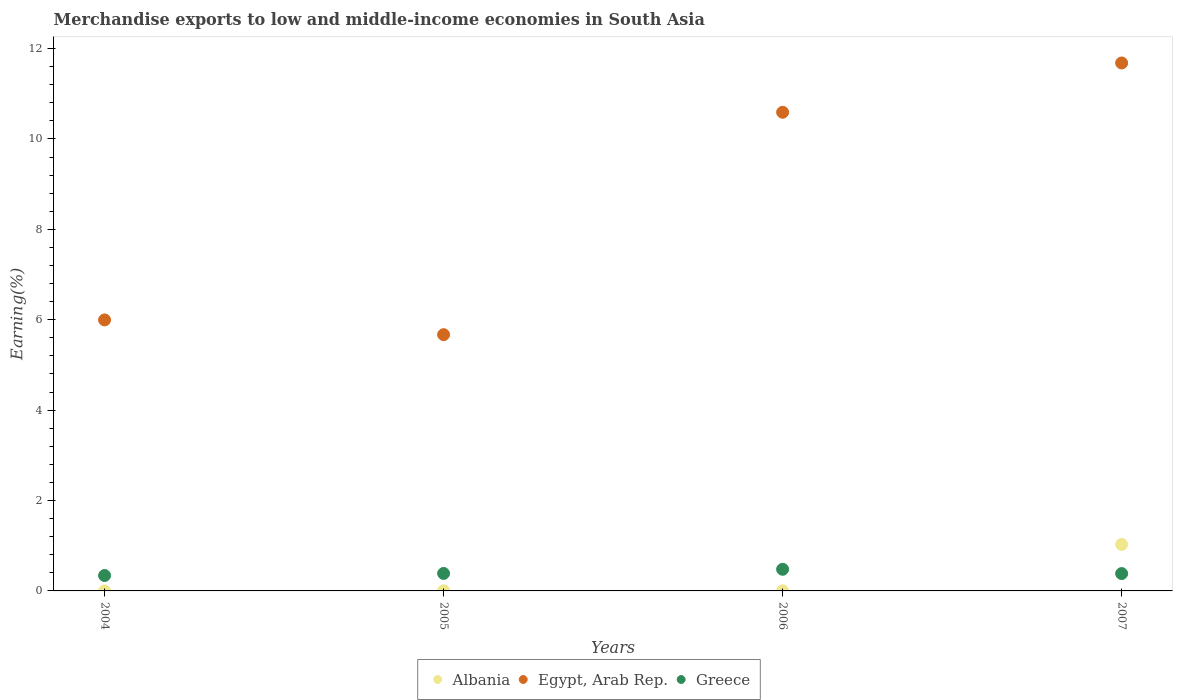Is the number of dotlines equal to the number of legend labels?
Offer a terse response. Yes. What is the percentage of amount earned from merchandise exports in Greece in 2005?
Your answer should be compact. 0.39. Across all years, what is the maximum percentage of amount earned from merchandise exports in Egypt, Arab Rep.?
Your answer should be compact. 11.68. Across all years, what is the minimum percentage of amount earned from merchandise exports in Greece?
Your response must be concise. 0.34. In which year was the percentage of amount earned from merchandise exports in Egypt, Arab Rep. minimum?
Your response must be concise. 2005. What is the total percentage of amount earned from merchandise exports in Egypt, Arab Rep. in the graph?
Provide a short and direct response. 33.94. What is the difference between the percentage of amount earned from merchandise exports in Greece in 2004 and that in 2007?
Offer a very short reply. -0.04. What is the difference between the percentage of amount earned from merchandise exports in Egypt, Arab Rep. in 2006 and the percentage of amount earned from merchandise exports in Greece in 2007?
Provide a succinct answer. 10.21. What is the average percentage of amount earned from merchandise exports in Albania per year?
Provide a succinct answer. 0.26. In the year 2007, what is the difference between the percentage of amount earned from merchandise exports in Greece and percentage of amount earned from merchandise exports in Egypt, Arab Rep.?
Offer a very short reply. -11.3. In how many years, is the percentage of amount earned from merchandise exports in Albania greater than 3.2 %?
Give a very brief answer. 0. What is the ratio of the percentage of amount earned from merchandise exports in Greece in 2006 to that in 2007?
Your response must be concise. 1.25. What is the difference between the highest and the second highest percentage of amount earned from merchandise exports in Greece?
Provide a short and direct response. 0.09. What is the difference between the highest and the lowest percentage of amount earned from merchandise exports in Albania?
Your answer should be compact. 1.03. Is the sum of the percentage of amount earned from merchandise exports in Albania in 2004 and 2006 greater than the maximum percentage of amount earned from merchandise exports in Egypt, Arab Rep. across all years?
Provide a succinct answer. No. Does the percentage of amount earned from merchandise exports in Greece monotonically increase over the years?
Ensure brevity in your answer.  No. Is the percentage of amount earned from merchandise exports in Greece strictly greater than the percentage of amount earned from merchandise exports in Albania over the years?
Keep it short and to the point. No. How many years are there in the graph?
Provide a short and direct response. 4. What is the difference between two consecutive major ticks on the Y-axis?
Provide a succinct answer. 2. Are the values on the major ticks of Y-axis written in scientific E-notation?
Give a very brief answer. No. Does the graph contain any zero values?
Your response must be concise. No. Does the graph contain grids?
Your answer should be very brief. No. How many legend labels are there?
Provide a succinct answer. 3. What is the title of the graph?
Offer a very short reply. Merchandise exports to low and middle-income economies in South Asia. What is the label or title of the X-axis?
Your answer should be compact. Years. What is the label or title of the Y-axis?
Keep it short and to the point. Earning(%). What is the Earning(%) in Albania in 2004?
Provide a succinct answer. 0. What is the Earning(%) in Egypt, Arab Rep. in 2004?
Give a very brief answer. 6. What is the Earning(%) of Greece in 2004?
Your answer should be very brief. 0.34. What is the Earning(%) in Albania in 2005?
Offer a terse response. 0. What is the Earning(%) of Egypt, Arab Rep. in 2005?
Your response must be concise. 5.67. What is the Earning(%) of Greece in 2005?
Make the answer very short. 0.39. What is the Earning(%) in Albania in 2006?
Keep it short and to the point. 0. What is the Earning(%) of Egypt, Arab Rep. in 2006?
Ensure brevity in your answer.  10.59. What is the Earning(%) of Greece in 2006?
Provide a succinct answer. 0.48. What is the Earning(%) of Albania in 2007?
Ensure brevity in your answer.  1.03. What is the Earning(%) of Egypt, Arab Rep. in 2007?
Offer a terse response. 11.68. What is the Earning(%) of Greece in 2007?
Ensure brevity in your answer.  0.38. Across all years, what is the maximum Earning(%) in Albania?
Offer a very short reply. 1.03. Across all years, what is the maximum Earning(%) of Egypt, Arab Rep.?
Offer a very short reply. 11.68. Across all years, what is the maximum Earning(%) of Greece?
Provide a succinct answer. 0.48. Across all years, what is the minimum Earning(%) of Albania?
Your answer should be compact. 0. Across all years, what is the minimum Earning(%) of Egypt, Arab Rep.?
Your answer should be compact. 5.67. Across all years, what is the minimum Earning(%) of Greece?
Offer a terse response. 0.34. What is the total Earning(%) in Albania in the graph?
Your answer should be very brief. 1.03. What is the total Earning(%) in Egypt, Arab Rep. in the graph?
Give a very brief answer. 33.94. What is the total Earning(%) in Greece in the graph?
Your response must be concise. 1.59. What is the difference between the Earning(%) of Albania in 2004 and that in 2005?
Make the answer very short. -0. What is the difference between the Earning(%) in Egypt, Arab Rep. in 2004 and that in 2005?
Provide a succinct answer. 0.33. What is the difference between the Earning(%) of Greece in 2004 and that in 2005?
Offer a very short reply. -0.05. What is the difference between the Earning(%) of Albania in 2004 and that in 2006?
Your answer should be compact. -0. What is the difference between the Earning(%) in Egypt, Arab Rep. in 2004 and that in 2006?
Ensure brevity in your answer.  -4.59. What is the difference between the Earning(%) in Greece in 2004 and that in 2006?
Your response must be concise. -0.14. What is the difference between the Earning(%) in Albania in 2004 and that in 2007?
Your answer should be compact. -1.03. What is the difference between the Earning(%) in Egypt, Arab Rep. in 2004 and that in 2007?
Keep it short and to the point. -5.69. What is the difference between the Earning(%) in Greece in 2004 and that in 2007?
Keep it short and to the point. -0.04. What is the difference between the Earning(%) of Albania in 2005 and that in 2006?
Offer a very short reply. 0. What is the difference between the Earning(%) of Egypt, Arab Rep. in 2005 and that in 2006?
Offer a very short reply. -4.92. What is the difference between the Earning(%) in Greece in 2005 and that in 2006?
Offer a terse response. -0.09. What is the difference between the Earning(%) in Albania in 2005 and that in 2007?
Offer a terse response. -1.03. What is the difference between the Earning(%) of Egypt, Arab Rep. in 2005 and that in 2007?
Keep it short and to the point. -6.01. What is the difference between the Earning(%) in Greece in 2005 and that in 2007?
Give a very brief answer. 0. What is the difference between the Earning(%) of Albania in 2006 and that in 2007?
Offer a very short reply. -1.03. What is the difference between the Earning(%) in Egypt, Arab Rep. in 2006 and that in 2007?
Provide a short and direct response. -1.09. What is the difference between the Earning(%) in Greece in 2006 and that in 2007?
Your answer should be very brief. 0.1. What is the difference between the Earning(%) in Albania in 2004 and the Earning(%) in Egypt, Arab Rep. in 2005?
Keep it short and to the point. -5.67. What is the difference between the Earning(%) in Albania in 2004 and the Earning(%) in Greece in 2005?
Ensure brevity in your answer.  -0.39. What is the difference between the Earning(%) in Egypt, Arab Rep. in 2004 and the Earning(%) in Greece in 2005?
Your response must be concise. 5.61. What is the difference between the Earning(%) of Albania in 2004 and the Earning(%) of Egypt, Arab Rep. in 2006?
Provide a short and direct response. -10.59. What is the difference between the Earning(%) of Albania in 2004 and the Earning(%) of Greece in 2006?
Your answer should be compact. -0.48. What is the difference between the Earning(%) in Egypt, Arab Rep. in 2004 and the Earning(%) in Greece in 2006?
Provide a succinct answer. 5.52. What is the difference between the Earning(%) in Albania in 2004 and the Earning(%) in Egypt, Arab Rep. in 2007?
Make the answer very short. -11.68. What is the difference between the Earning(%) of Albania in 2004 and the Earning(%) of Greece in 2007?
Your answer should be very brief. -0.38. What is the difference between the Earning(%) of Egypt, Arab Rep. in 2004 and the Earning(%) of Greece in 2007?
Your response must be concise. 5.61. What is the difference between the Earning(%) in Albania in 2005 and the Earning(%) in Egypt, Arab Rep. in 2006?
Keep it short and to the point. -10.59. What is the difference between the Earning(%) of Albania in 2005 and the Earning(%) of Greece in 2006?
Provide a short and direct response. -0.48. What is the difference between the Earning(%) in Egypt, Arab Rep. in 2005 and the Earning(%) in Greece in 2006?
Your response must be concise. 5.19. What is the difference between the Earning(%) of Albania in 2005 and the Earning(%) of Egypt, Arab Rep. in 2007?
Your response must be concise. -11.68. What is the difference between the Earning(%) in Albania in 2005 and the Earning(%) in Greece in 2007?
Ensure brevity in your answer.  -0.38. What is the difference between the Earning(%) of Egypt, Arab Rep. in 2005 and the Earning(%) of Greece in 2007?
Offer a very short reply. 5.29. What is the difference between the Earning(%) in Albania in 2006 and the Earning(%) in Egypt, Arab Rep. in 2007?
Provide a succinct answer. -11.68. What is the difference between the Earning(%) in Albania in 2006 and the Earning(%) in Greece in 2007?
Your answer should be very brief. -0.38. What is the difference between the Earning(%) of Egypt, Arab Rep. in 2006 and the Earning(%) of Greece in 2007?
Provide a short and direct response. 10.21. What is the average Earning(%) of Albania per year?
Offer a very short reply. 0.26. What is the average Earning(%) in Egypt, Arab Rep. per year?
Provide a short and direct response. 8.48. What is the average Earning(%) in Greece per year?
Offer a very short reply. 0.4. In the year 2004, what is the difference between the Earning(%) in Albania and Earning(%) in Egypt, Arab Rep.?
Your answer should be very brief. -6. In the year 2004, what is the difference between the Earning(%) of Albania and Earning(%) of Greece?
Your response must be concise. -0.34. In the year 2004, what is the difference between the Earning(%) of Egypt, Arab Rep. and Earning(%) of Greece?
Provide a short and direct response. 5.66. In the year 2005, what is the difference between the Earning(%) in Albania and Earning(%) in Egypt, Arab Rep.?
Offer a very short reply. -5.67. In the year 2005, what is the difference between the Earning(%) in Albania and Earning(%) in Greece?
Your answer should be compact. -0.38. In the year 2005, what is the difference between the Earning(%) in Egypt, Arab Rep. and Earning(%) in Greece?
Offer a very short reply. 5.28. In the year 2006, what is the difference between the Earning(%) in Albania and Earning(%) in Egypt, Arab Rep.?
Your answer should be very brief. -10.59. In the year 2006, what is the difference between the Earning(%) in Albania and Earning(%) in Greece?
Your response must be concise. -0.48. In the year 2006, what is the difference between the Earning(%) of Egypt, Arab Rep. and Earning(%) of Greece?
Your answer should be very brief. 10.11. In the year 2007, what is the difference between the Earning(%) in Albania and Earning(%) in Egypt, Arab Rep.?
Provide a succinct answer. -10.65. In the year 2007, what is the difference between the Earning(%) in Albania and Earning(%) in Greece?
Offer a terse response. 0.65. In the year 2007, what is the difference between the Earning(%) of Egypt, Arab Rep. and Earning(%) of Greece?
Provide a succinct answer. 11.3. What is the ratio of the Earning(%) of Albania in 2004 to that in 2005?
Your answer should be very brief. 0.2. What is the ratio of the Earning(%) of Egypt, Arab Rep. in 2004 to that in 2005?
Your response must be concise. 1.06. What is the ratio of the Earning(%) in Greece in 2004 to that in 2005?
Your answer should be very brief. 0.88. What is the ratio of the Earning(%) of Albania in 2004 to that in 2006?
Your answer should be compact. 0.29. What is the ratio of the Earning(%) in Egypt, Arab Rep. in 2004 to that in 2006?
Offer a very short reply. 0.57. What is the ratio of the Earning(%) of Greece in 2004 to that in 2006?
Your answer should be very brief. 0.71. What is the ratio of the Earning(%) in Albania in 2004 to that in 2007?
Provide a short and direct response. 0. What is the ratio of the Earning(%) in Egypt, Arab Rep. in 2004 to that in 2007?
Ensure brevity in your answer.  0.51. What is the ratio of the Earning(%) of Greece in 2004 to that in 2007?
Provide a succinct answer. 0.89. What is the ratio of the Earning(%) in Albania in 2005 to that in 2006?
Your answer should be very brief. 1.43. What is the ratio of the Earning(%) of Egypt, Arab Rep. in 2005 to that in 2006?
Your answer should be compact. 0.54. What is the ratio of the Earning(%) in Greece in 2005 to that in 2006?
Your answer should be compact. 0.81. What is the ratio of the Earning(%) of Albania in 2005 to that in 2007?
Your answer should be very brief. 0. What is the ratio of the Earning(%) in Egypt, Arab Rep. in 2005 to that in 2007?
Your response must be concise. 0.49. What is the ratio of the Earning(%) in Greece in 2005 to that in 2007?
Give a very brief answer. 1.01. What is the ratio of the Earning(%) of Albania in 2006 to that in 2007?
Keep it short and to the point. 0. What is the ratio of the Earning(%) of Egypt, Arab Rep. in 2006 to that in 2007?
Offer a terse response. 0.91. What is the ratio of the Earning(%) of Greece in 2006 to that in 2007?
Provide a succinct answer. 1.25. What is the difference between the highest and the second highest Earning(%) of Albania?
Your response must be concise. 1.03. What is the difference between the highest and the second highest Earning(%) of Egypt, Arab Rep.?
Your answer should be compact. 1.09. What is the difference between the highest and the second highest Earning(%) in Greece?
Make the answer very short. 0.09. What is the difference between the highest and the lowest Earning(%) of Albania?
Your response must be concise. 1.03. What is the difference between the highest and the lowest Earning(%) in Egypt, Arab Rep.?
Provide a succinct answer. 6.01. What is the difference between the highest and the lowest Earning(%) in Greece?
Offer a terse response. 0.14. 